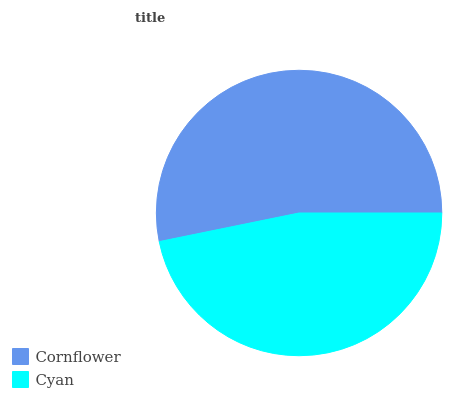Is Cyan the minimum?
Answer yes or no. Yes. Is Cornflower the maximum?
Answer yes or no. Yes. Is Cyan the maximum?
Answer yes or no. No. Is Cornflower greater than Cyan?
Answer yes or no. Yes. Is Cyan less than Cornflower?
Answer yes or no. Yes. Is Cyan greater than Cornflower?
Answer yes or no. No. Is Cornflower less than Cyan?
Answer yes or no. No. Is Cornflower the high median?
Answer yes or no. Yes. Is Cyan the low median?
Answer yes or no. Yes. Is Cyan the high median?
Answer yes or no. No. Is Cornflower the low median?
Answer yes or no. No. 